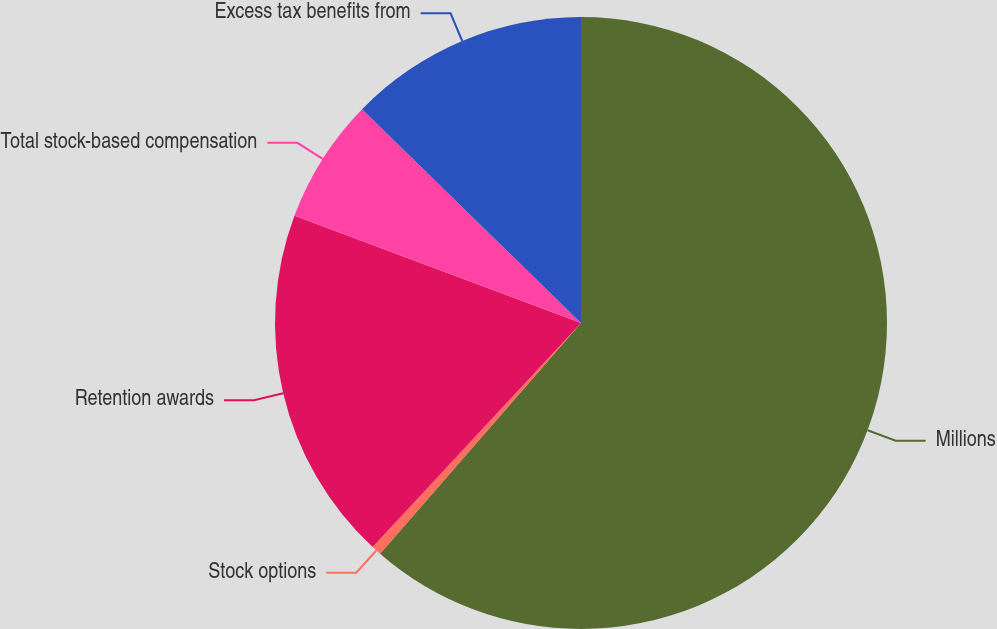Convert chart to OTSL. <chart><loc_0><loc_0><loc_500><loc_500><pie_chart><fcel>Millions<fcel>Stock options<fcel>Retention awards<fcel>Total stock-based compensation<fcel>Excess tax benefits from<nl><fcel>61.4%<fcel>0.52%<fcel>18.78%<fcel>6.61%<fcel>12.69%<nl></chart> 